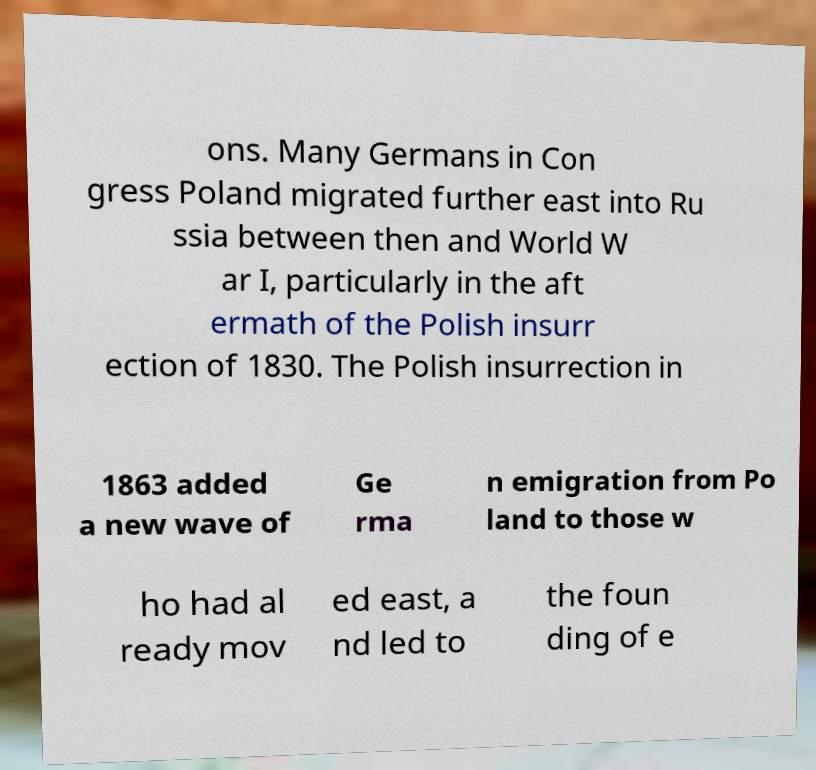Could you assist in decoding the text presented in this image and type it out clearly? ons. Many Germans in Con gress Poland migrated further east into Ru ssia between then and World W ar I, particularly in the aft ermath of the Polish insurr ection of 1830. The Polish insurrection in 1863 added a new wave of Ge rma n emigration from Po land to those w ho had al ready mov ed east, a nd led to the foun ding of e 